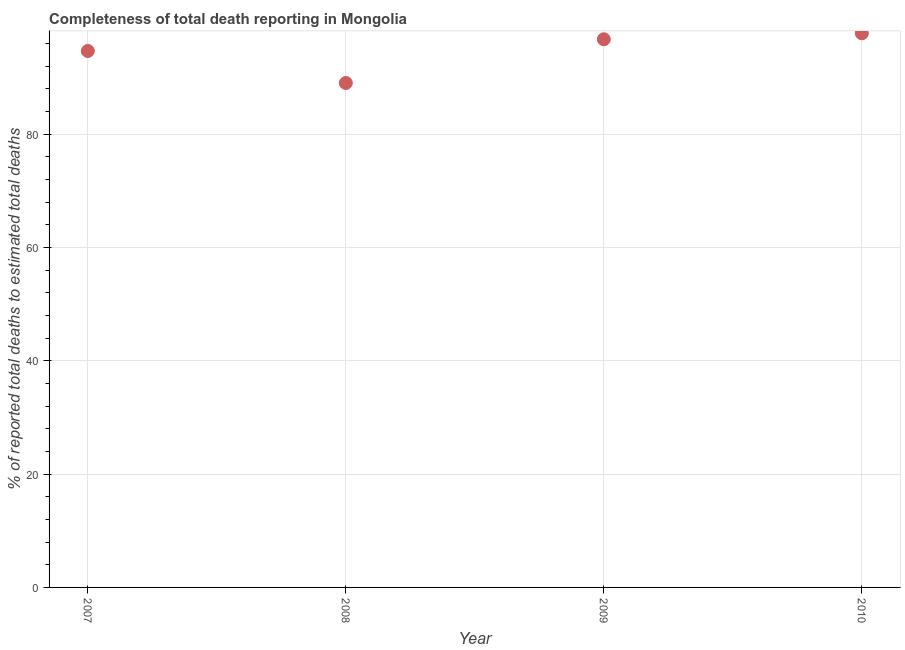What is the completeness of total death reports in 2008?
Your response must be concise. 89.04. Across all years, what is the maximum completeness of total death reports?
Your answer should be compact. 97.8. Across all years, what is the minimum completeness of total death reports?
Your response must be concise. 89.04. In which year was the completeness of total death reports maximum?
Give a very brief answer. 2010. In which year was the completeness of total death reports minimum?
Provide a succinct answer. 2008. What is the sum of the completeness of total death reports?
Offer a terse response. 378.27. What is the difference between the completeness of total death reports in 2007 and 2008?
Your answer should be compact. 5.65. What is the average completeness of total death reports per year?
Ensure brevity in your answer.  94.57. What is the median completeness of total death reports?
Offer a very short reply. 95.72. In how many years, is the completeness of total death reports greater than 4 %?
Provide a succinct answer. 4. What is the ratio of the completeness of total death reports in 2008 to that in 2009?
Offer a very short reply. 0.92. Is the difference between the completeness of total death reports in 2007 and 2008 greater than the difference between any two years?
Make the answer very short. No. What is the difference between the highest and the second highest completeness of total death reports?
Provide a succinct answer. 1.05. What is the difference between the highest and the lowest completeness of total death reports?
Give a very brief answer. 8.77. Does the completeness of total death reports monotonically increase over the years?
Make the answer very short. No. How many dotlines are there?
Provide a short and direct response. 1. How many years are there in the graph?
Provide a succinct answer. 4. What is the difference between two consecutive major ticks on the Y-axis?
Make the answer very short. 20. Are the values on the major ticks of Y-axis written in scientific E-notation?
Offer a terse response. No. Does the graph contain grids?
Your response must be concise. Yes. What is the title of the graph?
Ensure brevity in your answer.  Completeness of total death reporting in Mongolia. What is the label or title of the X-axis?
Give a very brief answer. Year. What is the label or title of the Y-axis?
Make the answer very short. % of reported total deaths to estimated total deaths. What is the % of reported total deaths to estimated total deaths in 2007?
Your response must be concise. 94.68. What is the % of reported total deaths to estimated total deaths in 2008?
Your answer should be compact. 89.04. What is the % of reported total deaths to estimated total deaths in 2009?
Give a very brief answer. 96.75. What is the % of reported total deaths to estimated total deaths in 2010?
Offer a very short reply. 97.8. What is the difference between the % of reported total deaths to estimated total deaths in 2007 and 2008?
Offer a terse response. 5.65. What is the difference between the % of reported total deaths to estimated total deaths in 2007 and 2009?
Make the answer very short. -2.07. What is the difference between the % of reported total deaths to estimated total deaths in 2007 and 2010?
Offer a very short reply. -3.12. What is the difference between the % of reported total deaths to estimated total deaths in 2008 and 2009?
Your answer should be compact. -7.71. What is the difference between the % of reported total deaths to estimated total deaths in 2008 and 2010?
Your answer should be very brief. -8.77. What is the difference between the % of reported total deaths to estimated total deaths in 2009 and 2010?
Give a very brief answer. -1.05. What is the ratio of the % of reported total deaths to estimated total deaths in 2007 to that in 2008?
Offer a very short reply. 1.06. What is the ratio of the % of reported total deaths to estimated total deaths in 2007 to that in 2009?
Offer a terse response. 0.98. What is the ratio of the % of reported total deaths to estimated total deaths in 2008 to that in 2009?
Provide a short and direct response. 0.92. What is the ratio of the % of reported total deaths to estimated total deaths in 2008 to that in 2010?
Your answer should be compact. 0.91. 